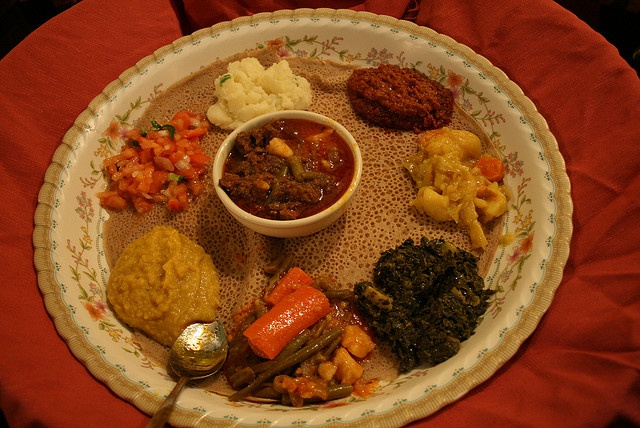Describe the objects in this image and their specific colors. I can see bowl in black, maroon, brown, and tan tones, broccoli in black, maroon, and olive tones, carrot in black, brown, and red tones, spoon in black, maroon, and olive tones, and carrot in black, brown, red, and maroon tones in this image. 